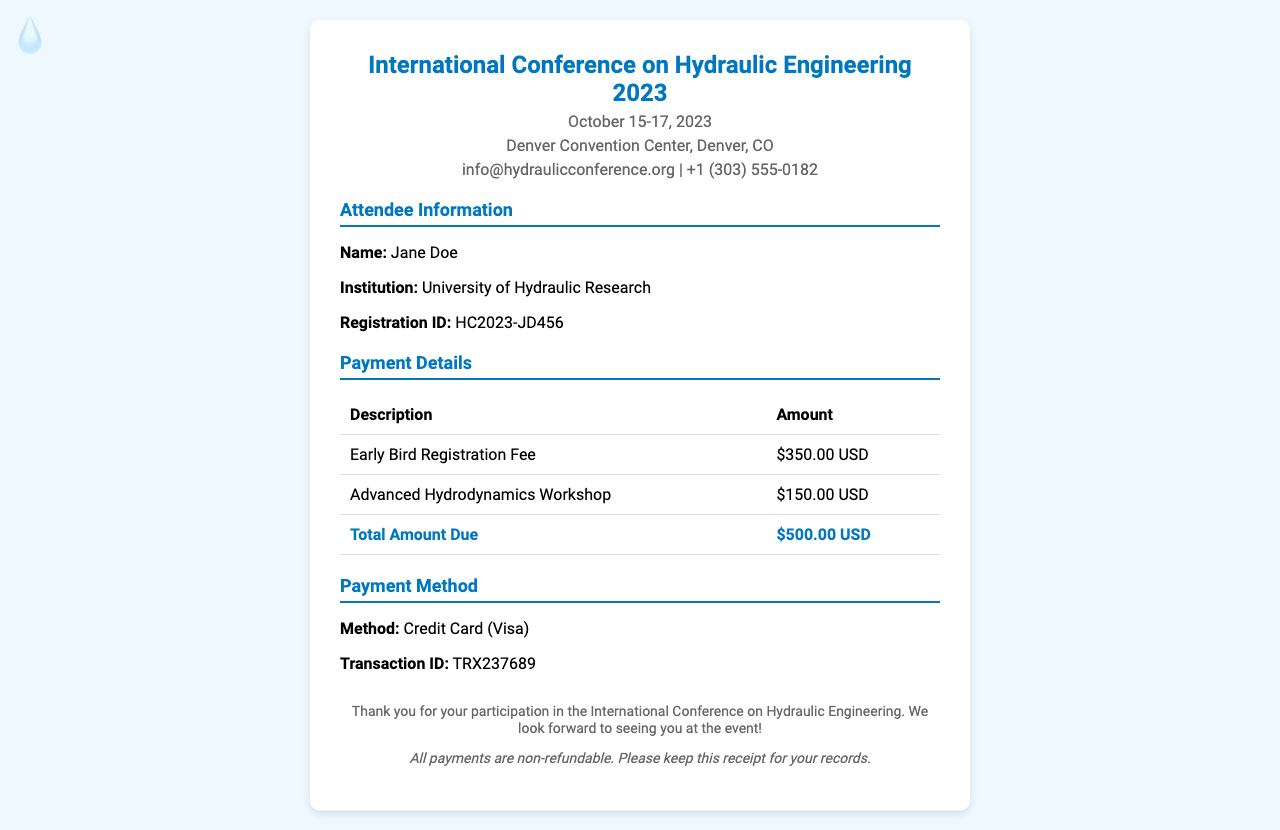What is the name of the conference? The conference is identified as the "International Conference on Hydraulic Engineering 2023."
Answer: International Conference on Hydraulic Engineering 2023 What are the dates of the conference? The document lists the conference dates as October 15-17, 2023.
Answer: October 15-17, 2023 What is the registration fee? The registration fee is specified as $350.00 USD in the payment details.
Answer: $350.00 USD Who is the attendee? The receipt indicates the attendee's name is Jane Doe.
Answer: Jane Doe What is the total amount due? The total amount due is the sum of the registration fee and workshop cost, which is stated as $500.00 USD.
Answer: $500.00 USD What type of workshop did the attendee register for? The document specifies the workshop as "Advanced Hydrodynamics Workshop."
Answer: Advanced Hydrodynamics Workshop What payment method was used? The payment method mentioned in the document is "Credit Card (Visa)."
Answer: Credit Card (Visa) What is the transaction ID? The receipt provides the transaction ID as TRX237689.
Answer: TRX237689 What is the name of the institution? The document lists the institution as "University of Hydraulic Research."
Answer: University of Hydraulic Research 